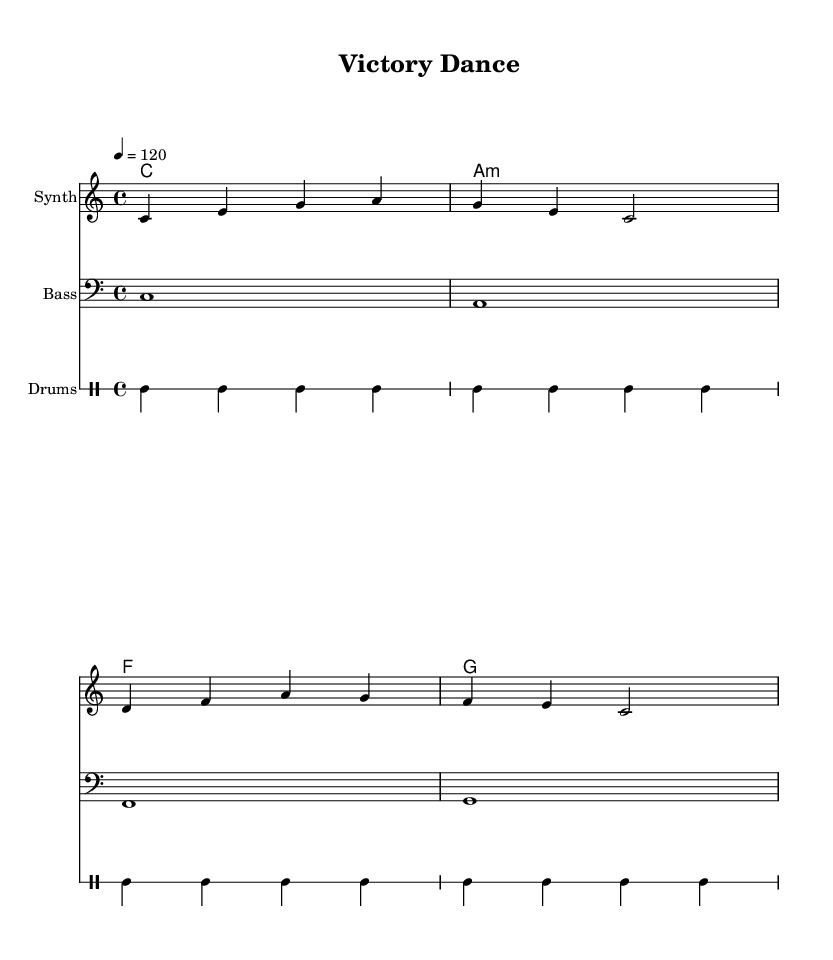What is the key signature of this music? The key signature is C major since it is indicated at the beginning of the score and contains no sharps or flats.
Answer: C major What is the time signature of this music? The time signature is 4/4, which is stated at the beginning of the score and indicates that there are four beats in each measure.
Answer: 4/4 What is the tempo marking of this music? The tempo marking is indicated by the number 120, which means the piece is to be played at 120 beats per minute.
Answer: 120 How many measures are in the melody? By counting the measures in the melody line, it is observed that there are four complete measures shown in the provided staff.
Answer: 4 Which chord follows the A minor chord in the chord progression? The chord following A minor in the sequence is F major, as seen in the chord symbols listed from left to right.
Answer: F What instrument is designated for the melody? The instrument labeled for the melody part in the score is "Synth," which is indicated at the beginning of the corresponding staff.
Answer: Synth What type of music is this piece categorized under? This piece is categorized under Dance music, as indicated by the title "Victory Dance" and its upbeat tempo and structure typical of dance songs.
Answer: Dance 